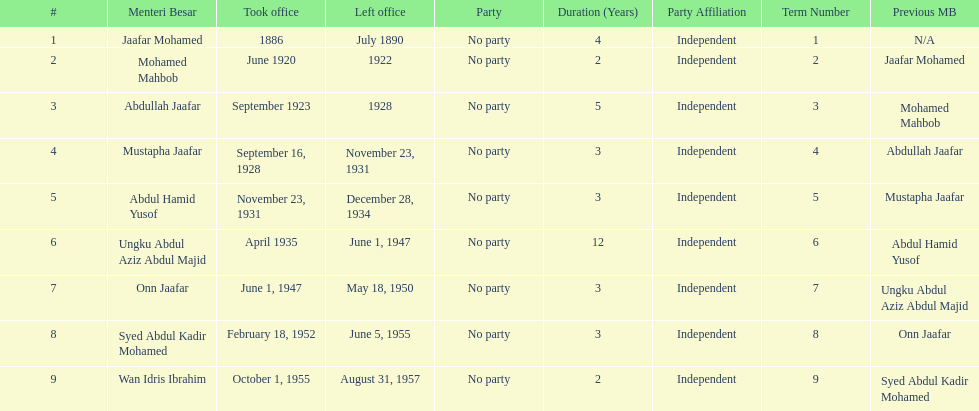How long did ungku abdul aziz abdul majid serve? 12 years. 